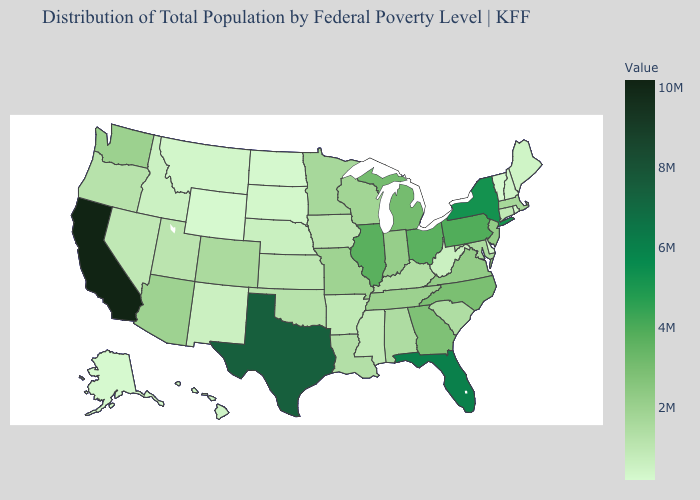Among the states that border West Virginia , which have the lowest value?
Short answer required. Kentucky. Does New Mexico have the highest value in the USA?
Concise answer only. No. Which states have the highest value in the USA?
Write a very short answer. California. Does Illinois have the highest value in the MidWest?
Quick response, please. Yes. Does the map have missing data?
Write a very short answer. No. Which states have the lowest value in the Northeast?
Short answer required. Vermont. Which states have the lowest value in the MidWest?
Short answer required. North Dakota. 